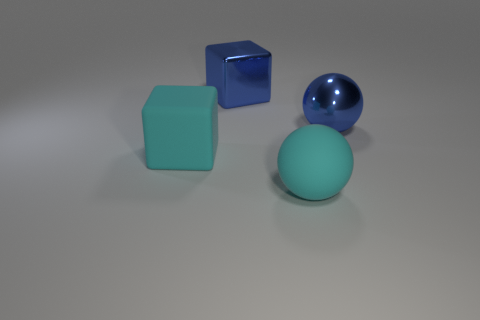The object that is behind the large cyan cube and left of the matte ball has what shape?
Offer a very short reply. Cube. What color is the big matte object to the right of the blue shiny cube?
Provide a short and direct response. Cyan. There is a thing that is both right of the big blue cube and behind the cyan sphere; how big is it?
Ensure brevity in your answer.  Large. Are the big cyan sphere and the large blue object left of the big blue ball made of the same material?
Provide a short and direct response. No. There is a large sphere that is the same color as the large shiny block; what material is it?
Offer a very short reply. Metal. How many blue spheres are there?
Offer a very short reply. 1. What number of objects are large metal blocks or big rubber blocks that are behind the large cyan ball?
Provide a succinct answer. 2. Are there any other things that have the same size as the matte sphere?
Ensure brevity in your answer.  Yes. Is the number of big matte things that are behind the blue block less than the number of large blue metallic cubes to the left of the cyan rubber sphere?
Keep it short and to the point. Yes. What size is the rubber thing that is in front of the cyan object that is behind the cyan thing that is in front of the big cyan matte cube?
Provide a succinct answer. Large. 